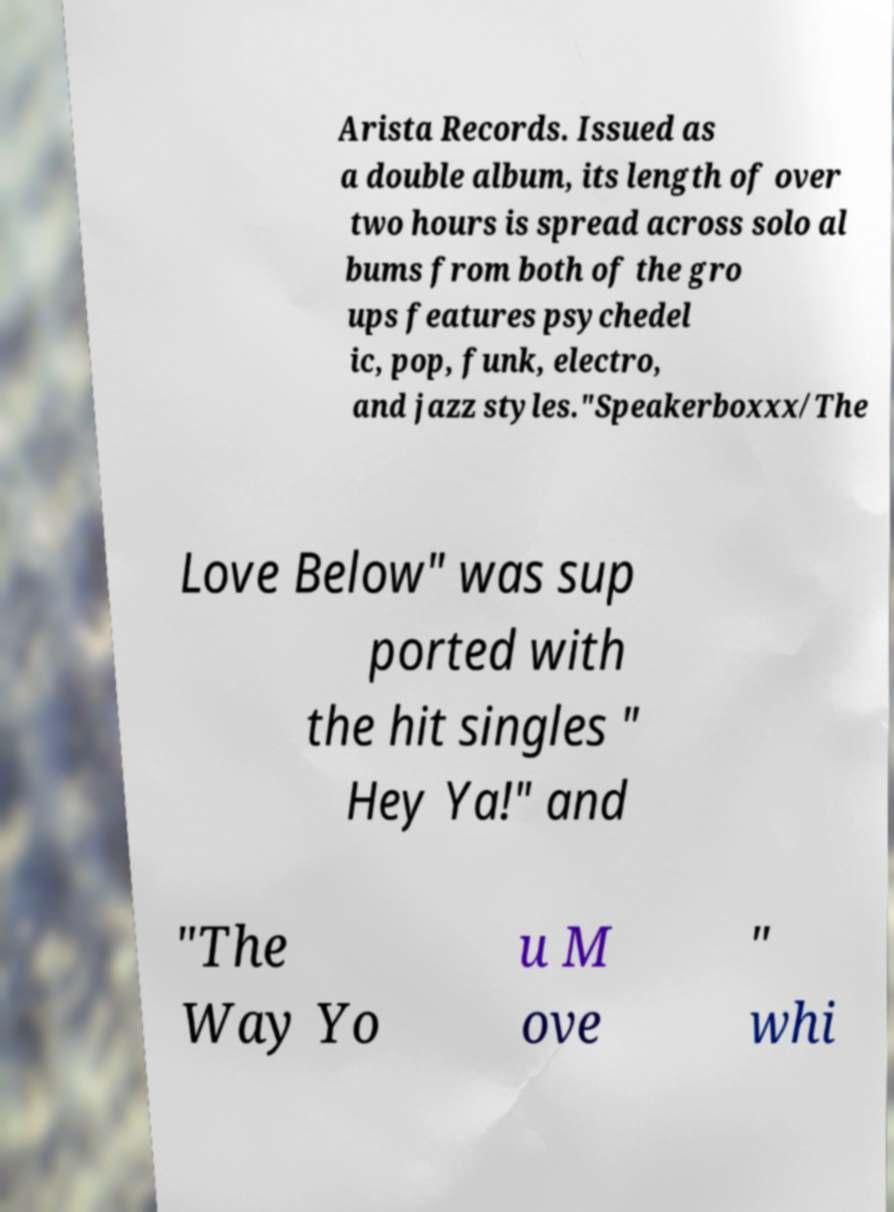Could you extract and type out the text from this image? Arista Records. Issued as a double album, its length of over two hours is spread across solo al bums from both of the gro ups features psychedel ic, pop, funk, electro, and jazz styles."Speakerboxxx/The Love Below" was sup ported with the hit singles " Hey Ya!" and "The Way Yo u M ove " whi 